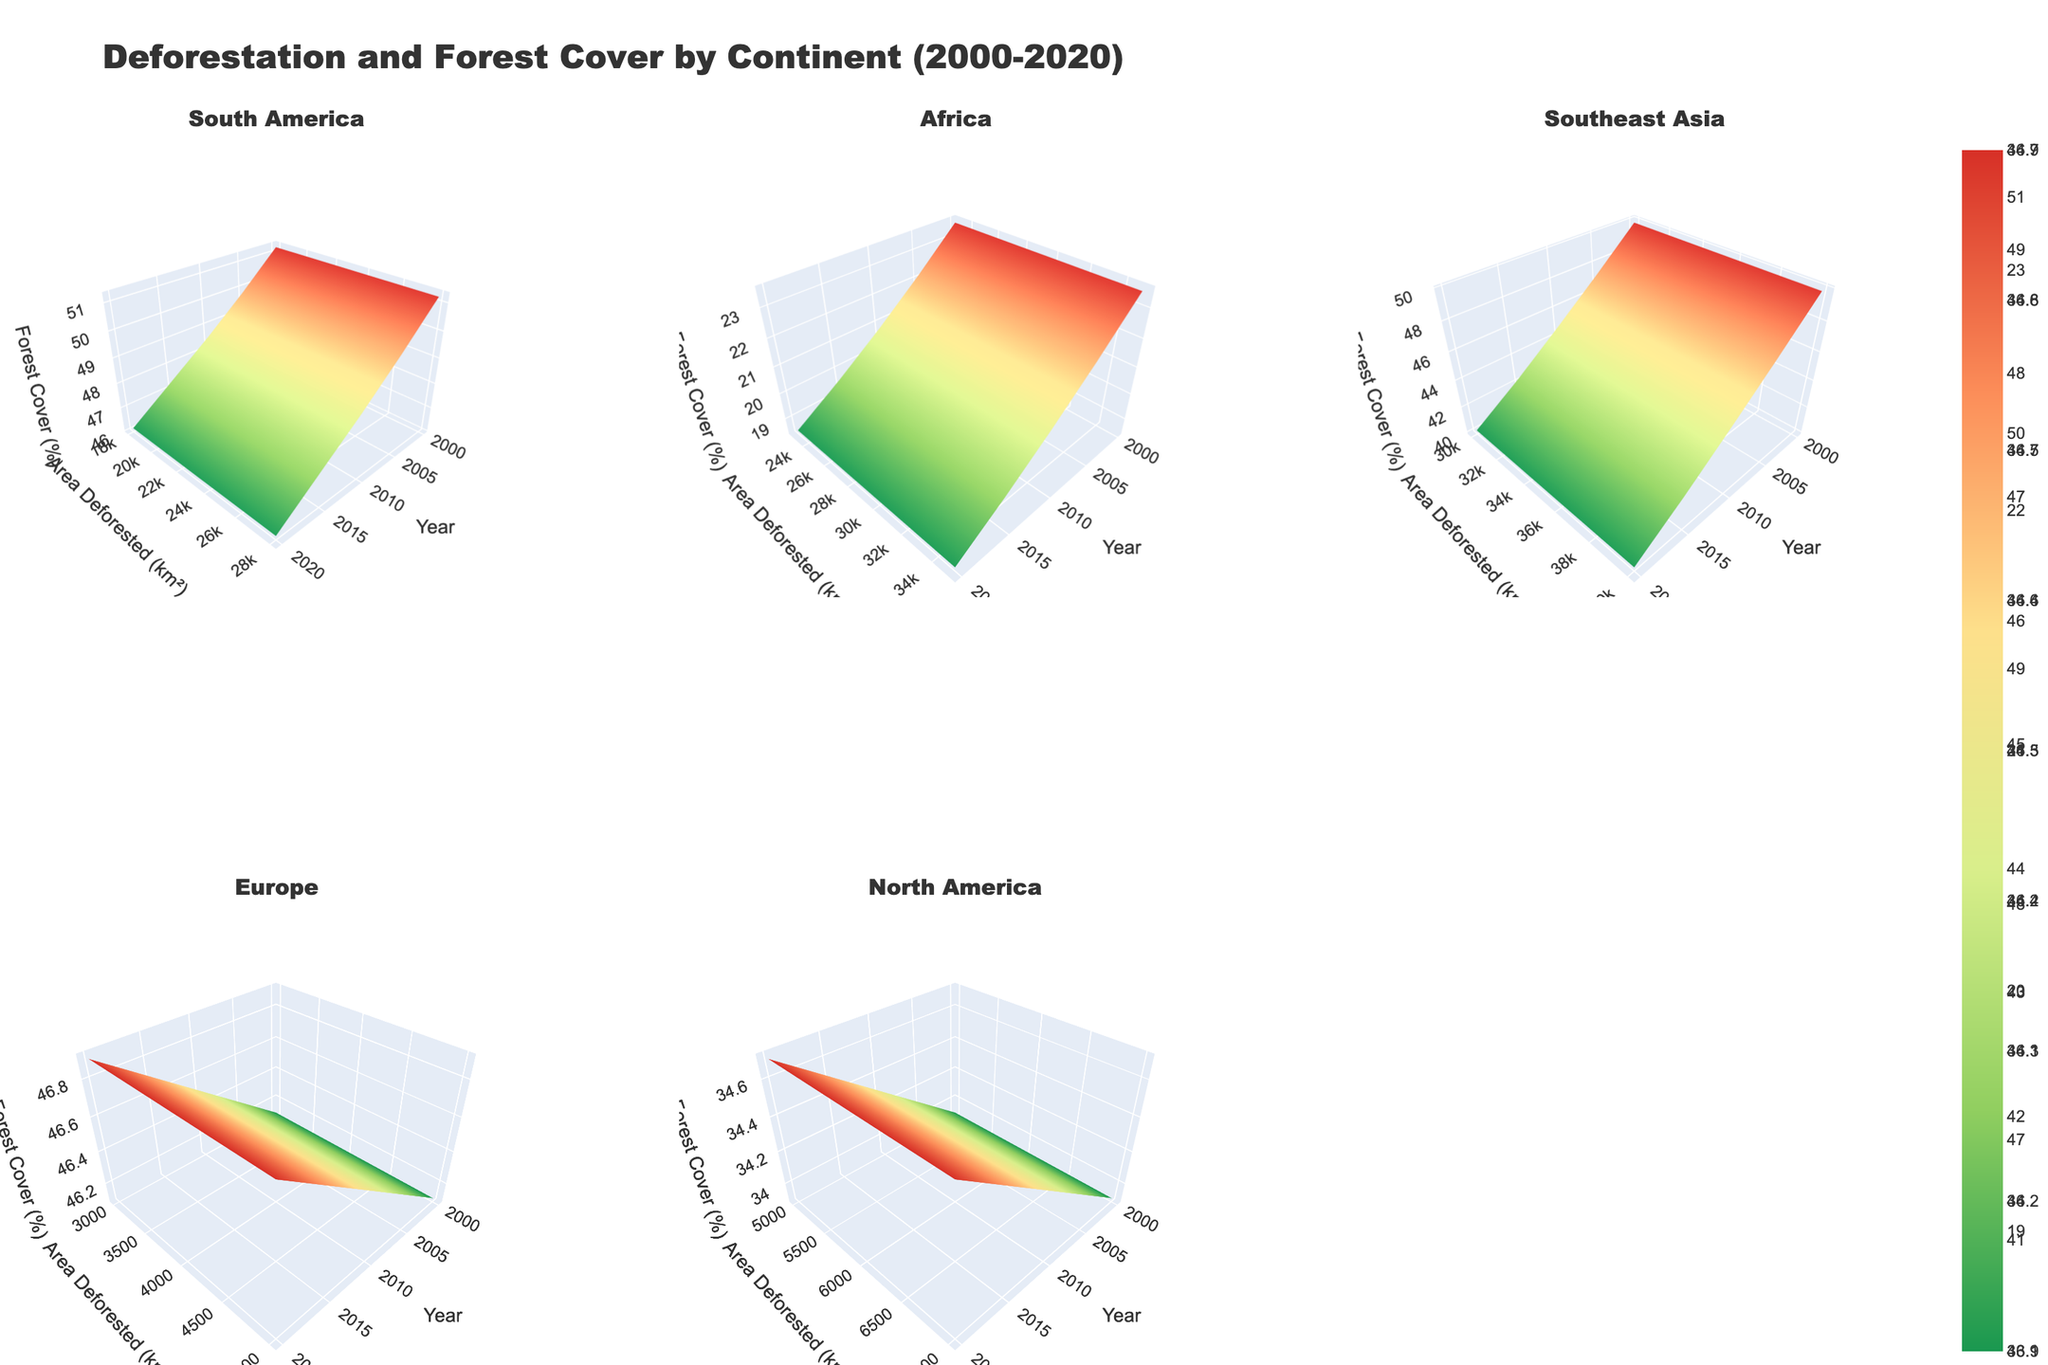What is the title of the figure? The title is clearly stated at the top of the figure.
Answer: Deforestation and Forest Cover by Continent (2000-2020) How many subplots are there in total? The figure consists of 2 rows and 3 columns of subplots.
Answer: 6 What does the x-axis represent across all subplots? Each subplot has its x-axis labeled, clearly indicating the measured variable.
Answer: Year Which continent has the highest area deforested in the year 2000? By looking at the data points in the plots for the year 2000, you can identify the subplot with the highest area value.
Answer: Southeast Asia How does the trend of forest cover percentage in Europe differ from trends in South America between 2000 and 2020? Look at the forest cover percentage axis and trace the trend lines in both subplots from 2000 to 2020. Europe's plot shows a slight increase, while South America's plot shows a significant decline.
Answer: Europe's forest cover increases slightly; South America's decreases significantly Rank the continents based on their area deforested in 2020, from highest to lowest. Compare the area deforested values for each subplot at the year 2020.
Answer: Southeast Asia, Africa, South America, North America, Europe In Southeast Asia, how much did the forest cover percentage drop from 2000 to 2020? Subtract the forest cover percentage in 2020 from that in 2000 for the Southeast Asia subplot. 49.8 (2000) - 40.1 (2020) = 9.7
Answer: 9.7% Which year shows the largest area deforested in Africa? Examine the Africa subplot and identify the peak value along the y-axis corresponding to different years.
Answer: 2000 Considering all continents, which one shows the most stable forest cover percentage over time? Compare the trends in forest cover percentage in all subplots and identify the one with the least variation.
Answer: Europe 